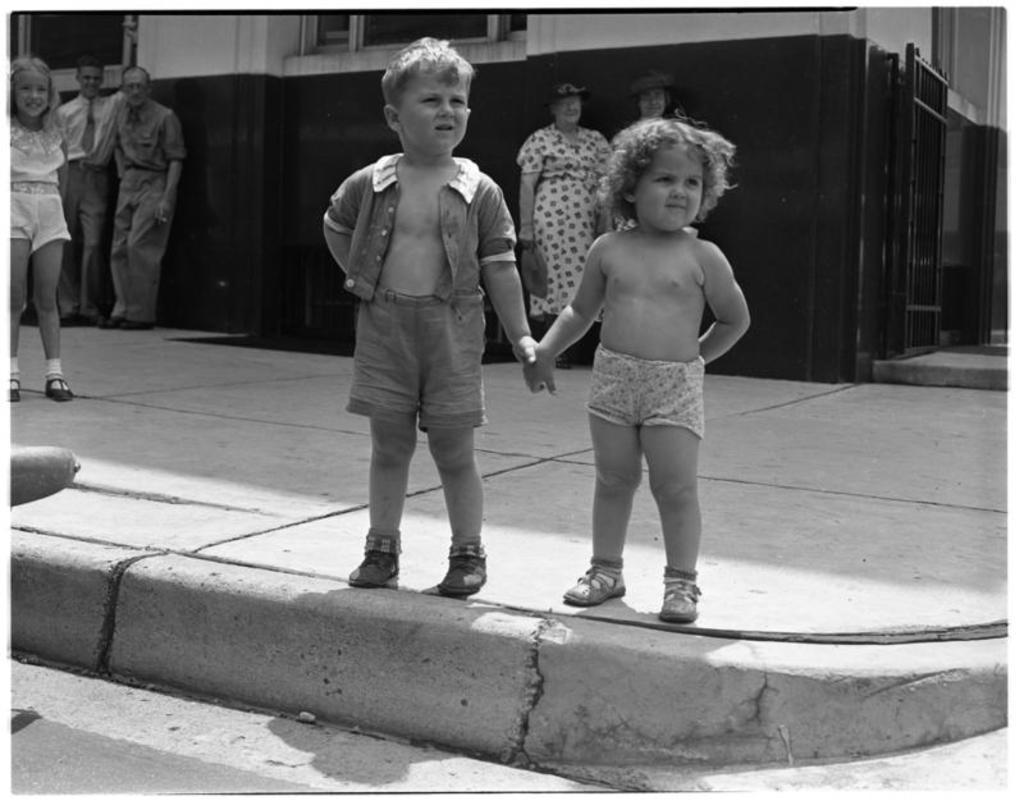How would you summarize this image in a sentence or two? In this picture we can see a girl and a boy holding hands and standing on the path. Few people are also visible on the path. We can see a building and a gate in the background. 